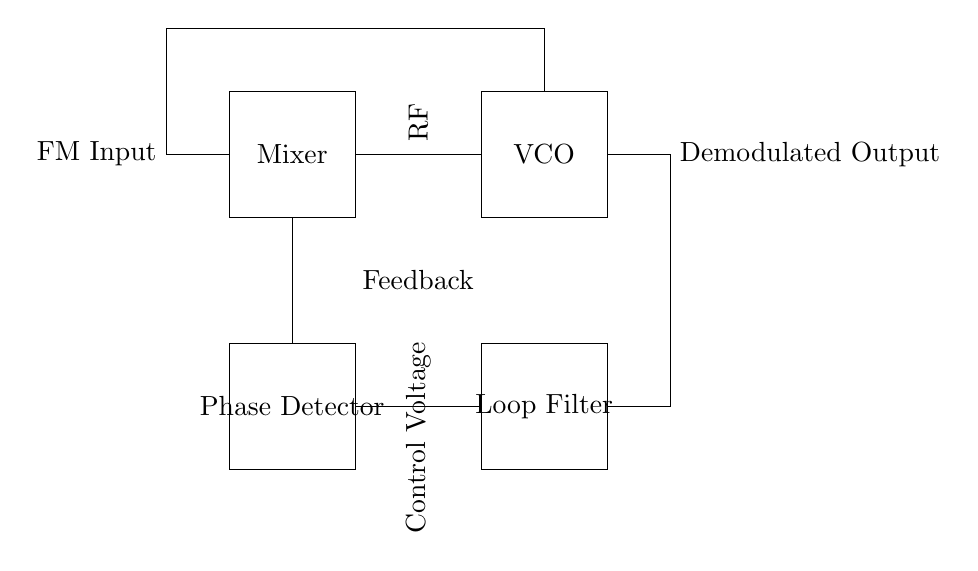What is the main component used for signal demodulation in this circuit? The main component for signal demodulation is the Mixer, which combines the FM input signal with the VCO signal.
Answer: Mixer What signals are connected to the Phase Detector? The input to the Phase Detector is the FM signal from the Mixer, which is compared to the output of the VCO for phase differences.
Answer: FM input and VCO output How many main functional blocks are there in this circuit? There are four main functional blocks: Mixer, Phase Detector, Loop Filter, and VCO.
Answer: Four What is the purpose of the Loop Filter in this circuit? The Loop Filter removes high-frequency noise and stabilizes the control voltage output to the VCO based on the phase differences detected.
Answer: Noise filtering What is the function of the voltage controlled oscillator (VCO) in this circuit? The function of the VCO is to generate an output signal whose frequency can be adjusted based on the control voltage from the Loop Filter, allowing for tuning to the desired FM signal.
Answer: Frequency tuning Which component provides the control voltage feedback in the circuit? The control voltage feedback is provided by the Loop Filter, which processes the output from the Phase Detector to control the VCO.
Answer: Loop Filter How does the VCO output connect to the demodulated output? The VCO output connects directly to the Demodulated Output, following the feedback and processing through the circuit, ensuring the signal is tuned and demodulated correctly.
Answer: Directly 